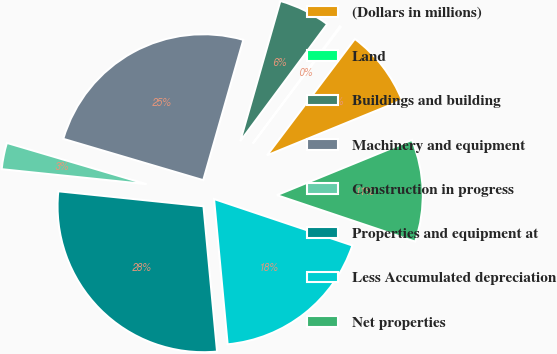Convert chart. <chart><loc_0><loc_0><loc_500><loc_500><pie_chart><fcel>(Dollars in millions)<fcel>Land<fcel>Buildings and building<fcel>Machinery and equipment<fcel>Construction in progress<fcel>Properties and equipment at<fcel>Less Accumulated depreciation<fcel>Net properties<nl><fcel>8.53%<fcel>0.13%<fcel>5.73%<fcel>24.86%<fcel>2.93%<fcel>28.12%<fcel>18.36%<fcel>11.33%<nl></chart> 